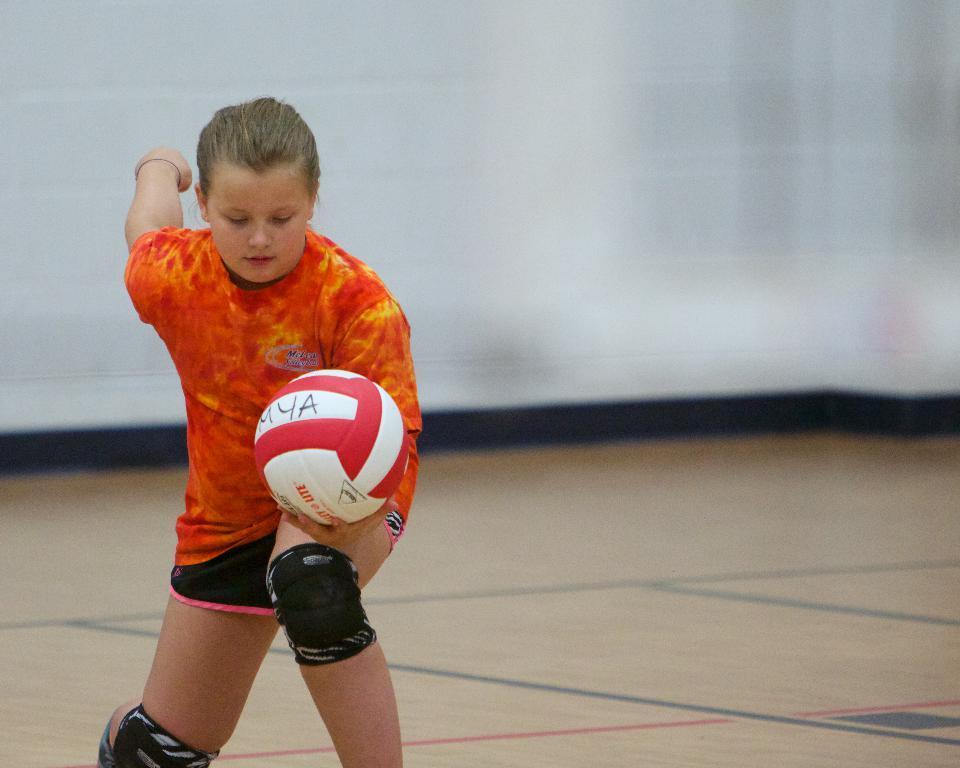Could you give a brief overview of what you see in this image? In this image, we can see a person wearing knee caps and holding a ball. In the background, there is a wall and at the bottom, there is a floor. 